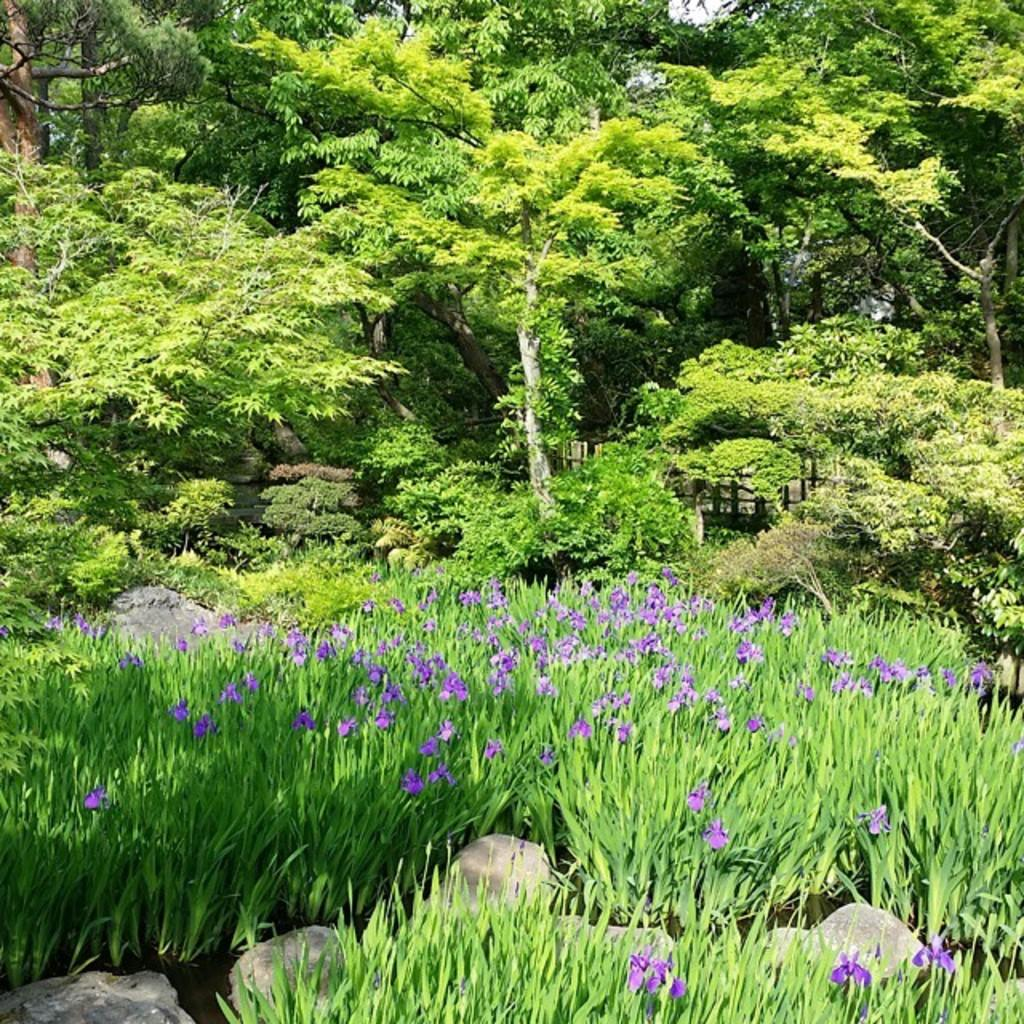What type of vegetation is at the bottom of the image? There are flower plants at the bottom of the image. What type of vegetation is at the top of the image? There are trees at the top of the image. What material is present between the plants in the image? There are stones present between the plants in the image. What type of club can be seen in the image? There is no club present in the image. What type of bean is growing among the flower plants in the image? There are no beans present among the flower plants in the image. 